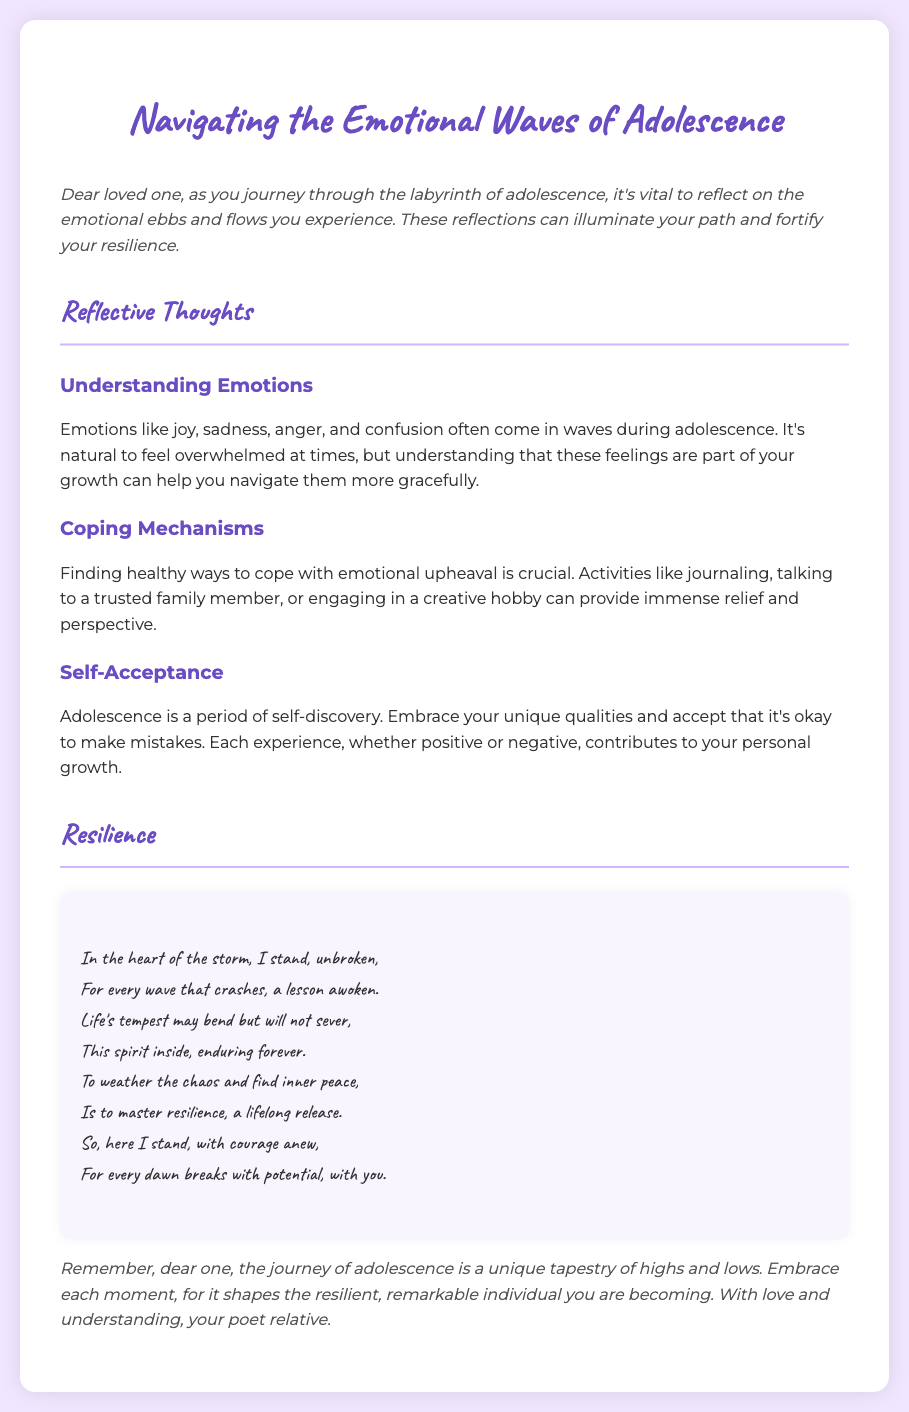what is the title of the document? The title is clearly stated at the top of the document.
Answer: Navigating the Emotional Waves of Adolescence who is the intended audience of the document? The audience is implied through the message addressed within the document.
Answer: loved one what are two emotions mentioned in the reflections? The emotions are listed in the section discussing emotional experiences during adolescence.
Answer: joy, sadness what is one coping mechanism suggested in the document? The document provides options for coping strategies in the coping mechanisms section.
Answer: journaling how many reflective thoughts are presented in the document? The number of sections under "Reflective Thoughts" states the total reflections.
Answer: three what is the overarching theme of the poem included? The theme of the poem is inferred from the lines discussing enduring through challenges.
Answer: resilience what is a key takeaway from the introduction? The introduction highlights the importance of reflecting on emotions during adolescence.
Answer: reflect on the emotional ebbs and flows what does the document suggest about self-acceptance? The document presents self-acceptance as part of personal growth during adolescence.
Answer: embrace your unique qualities what is the closing remark's tone? The tone of the closing remark reflects the overall sentiment of the document.
Answer: encouraging 